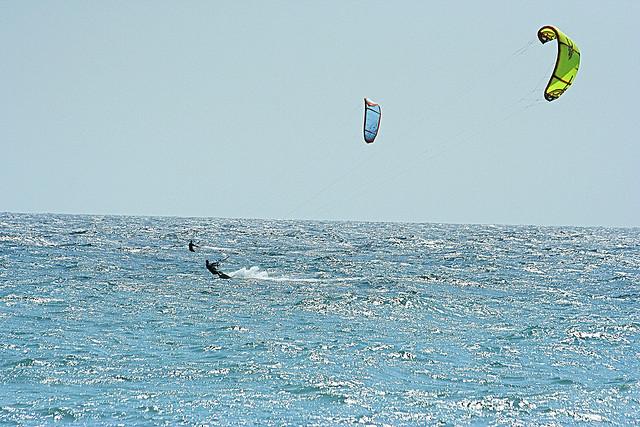How is the surfer towed?
Quick response, please. Kite. Do you think they are gliding too close together?
Give a very brief answer. No. Are these sky surfers moving fast?
Short answer required. Yes. Is the green one higher than the blue one?
Quick response, please. Yes. 